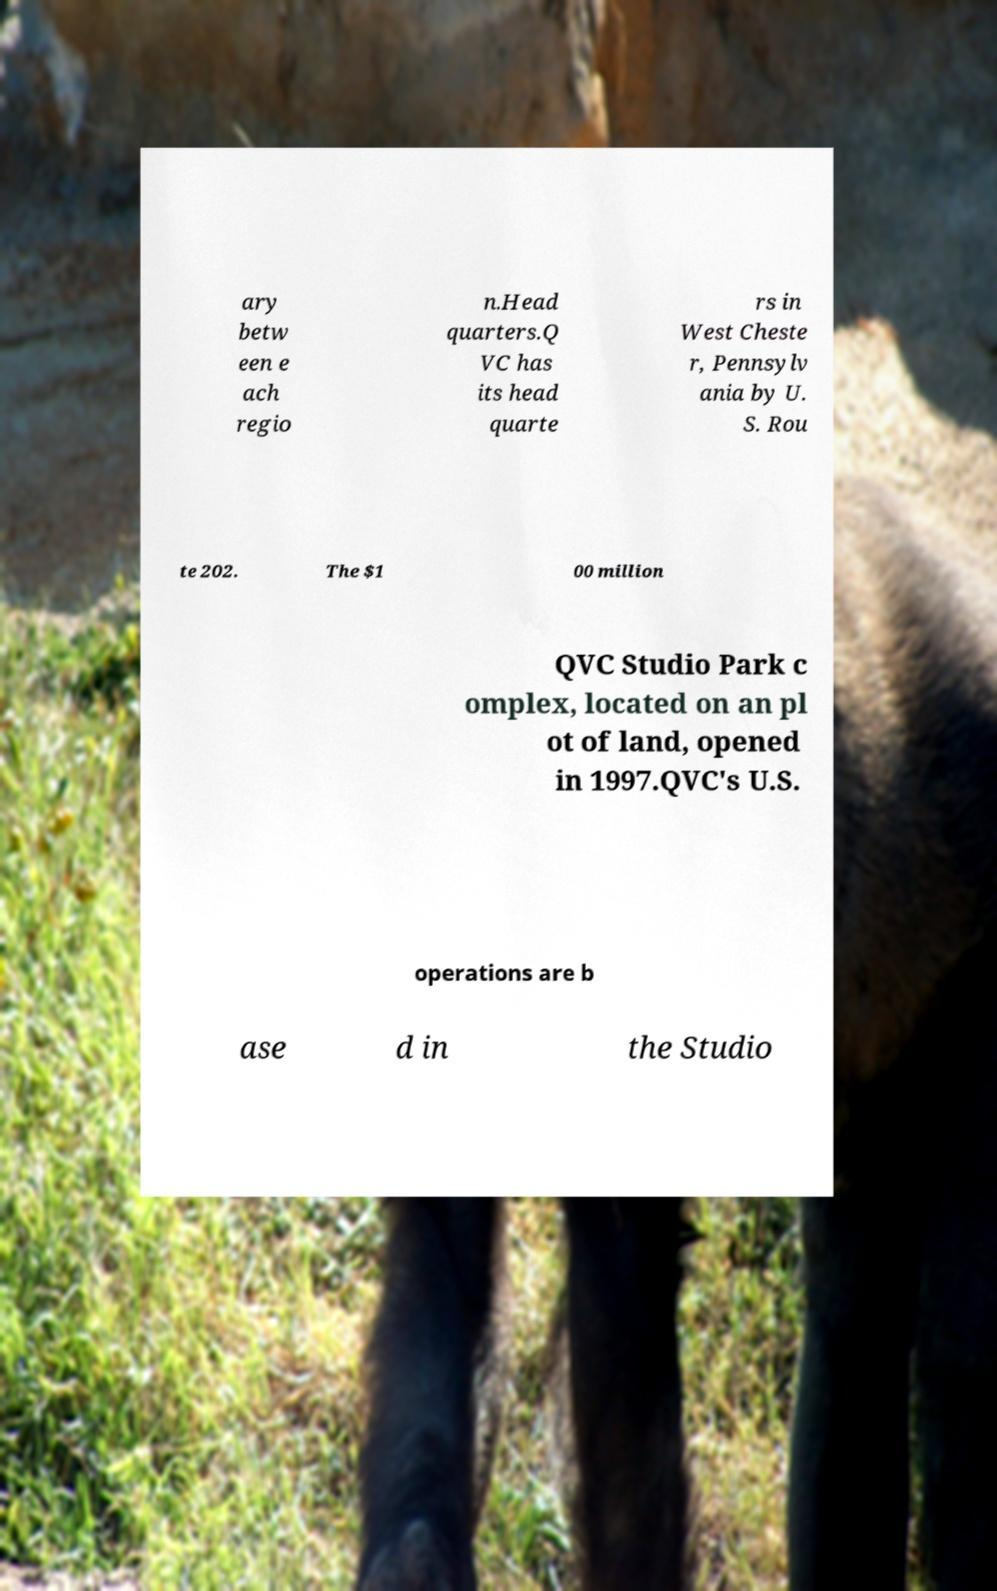For documentation purposes, I need the text within this image transcribed. Could you provide that? ary betw een e ach regio n.Head quarters.Q VC has its head quarte rs in West Cheste r, Pennsylv ania by U. S. Rou te 202. The $1 00 million QVC Studio Park c omplex, located on an pl ot of land, opened in 1997.QVC's U.S. operations are b ase d in the Studio 